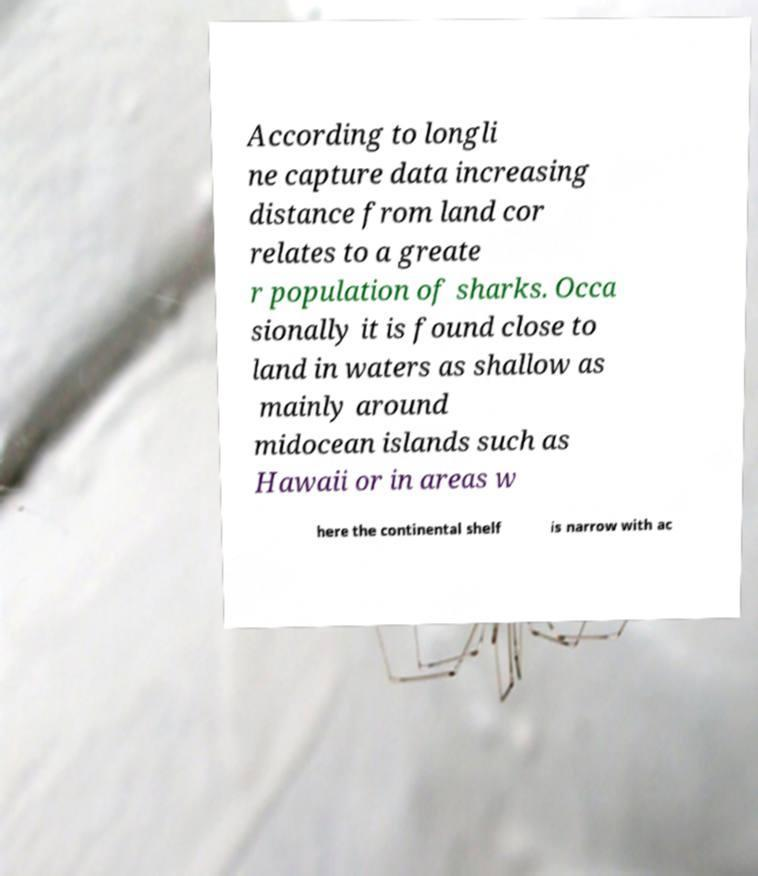Could you extract and type out the text from this image? According to longli ne capture data increasing distance from land cor relates to a greate r population of sharks. Occa sionally it is found close to land in waters as shallow as mainly around midocean islands such as Hawaii or in areas w here the continental shelf is narrow with ac 